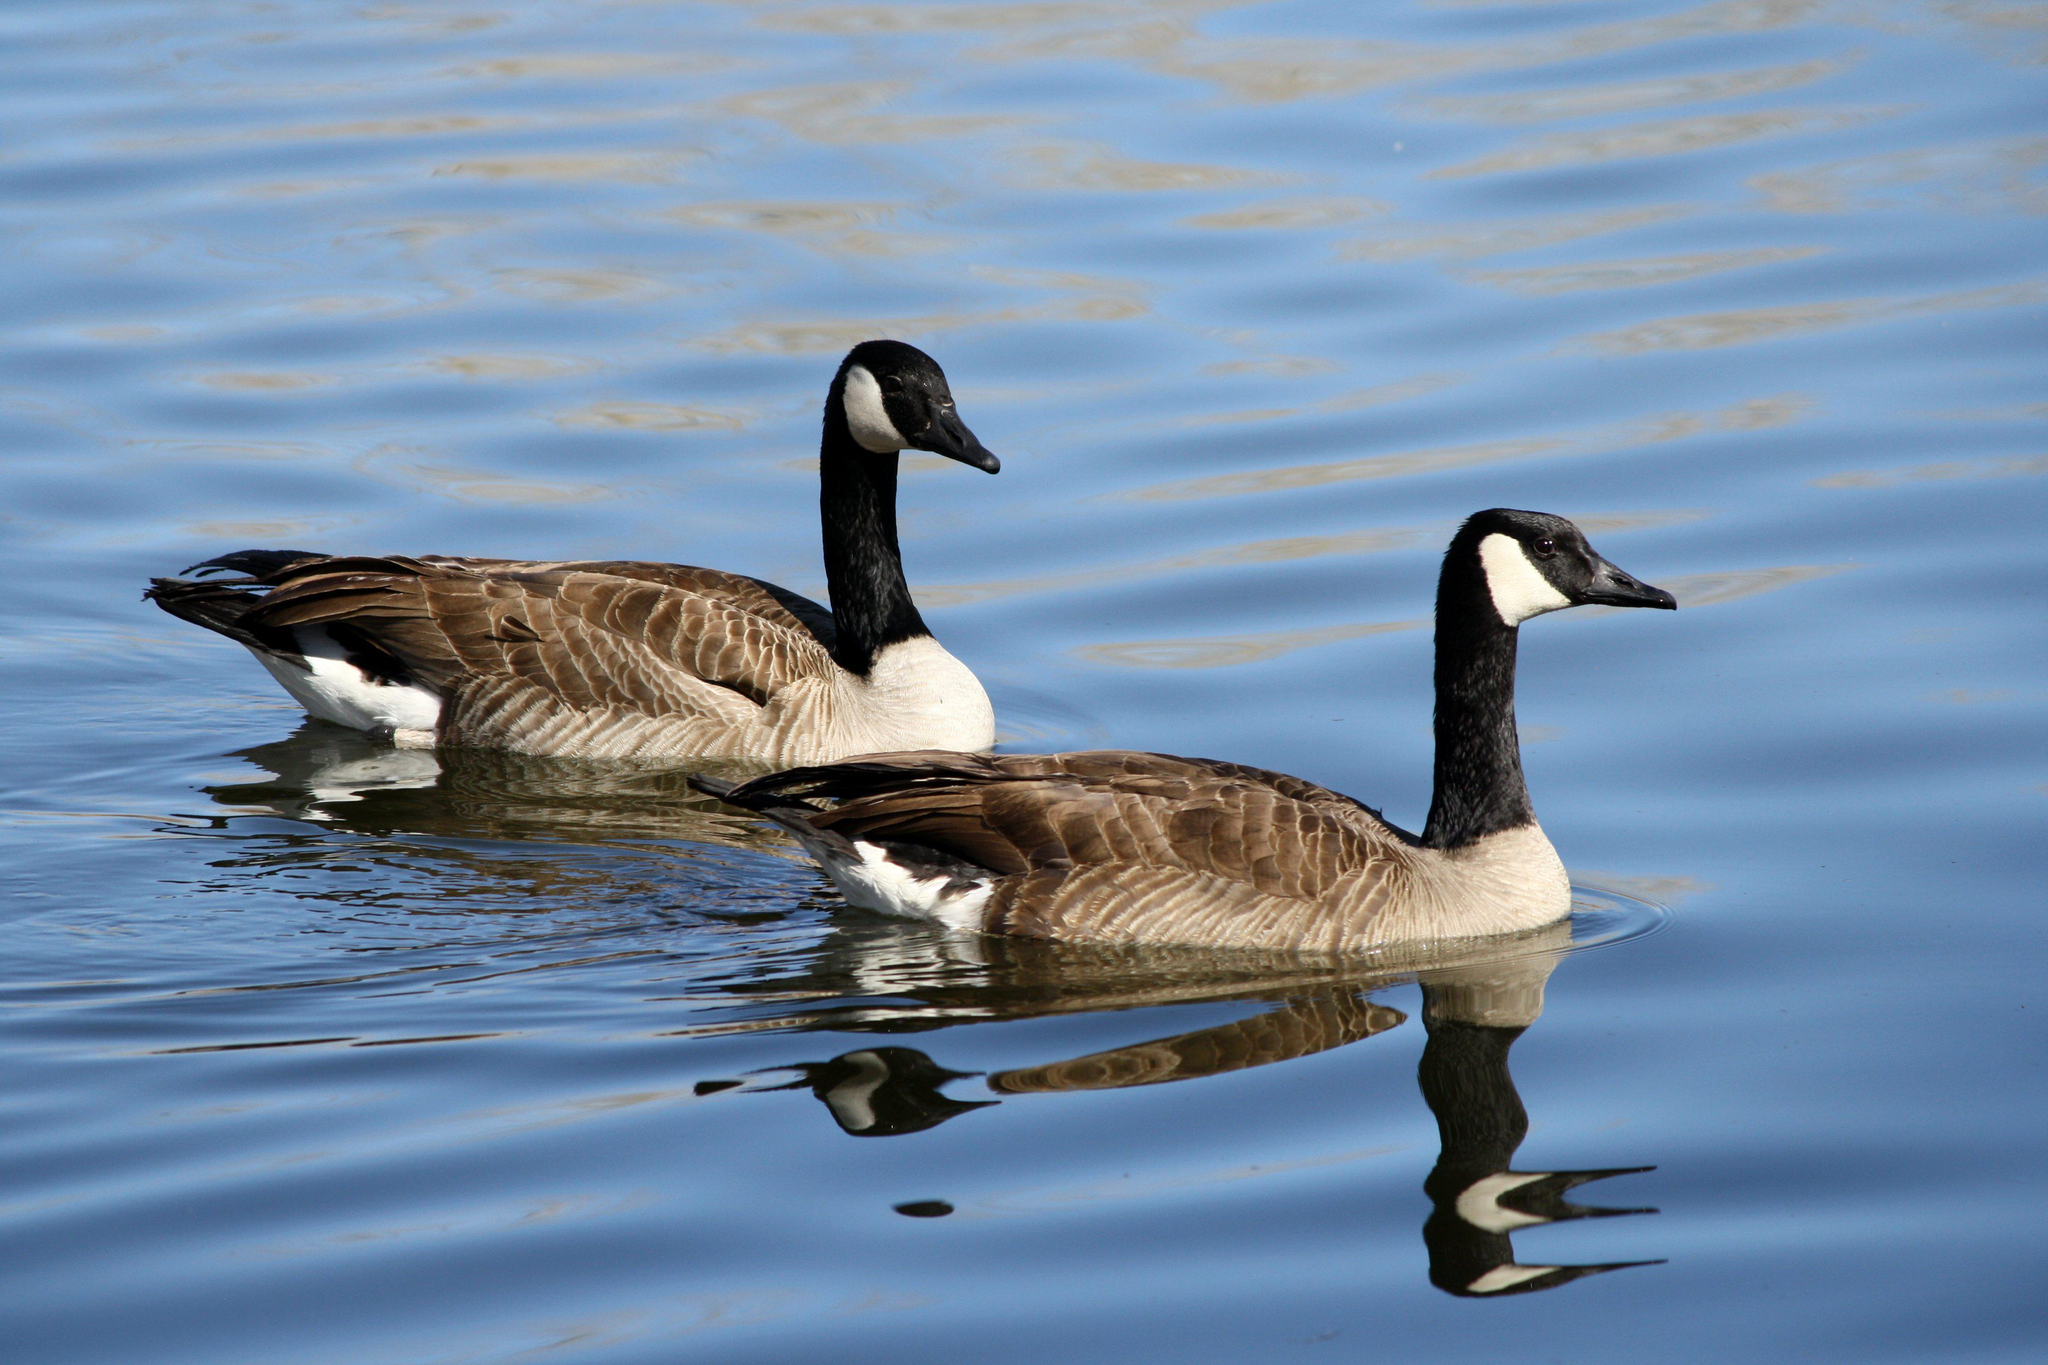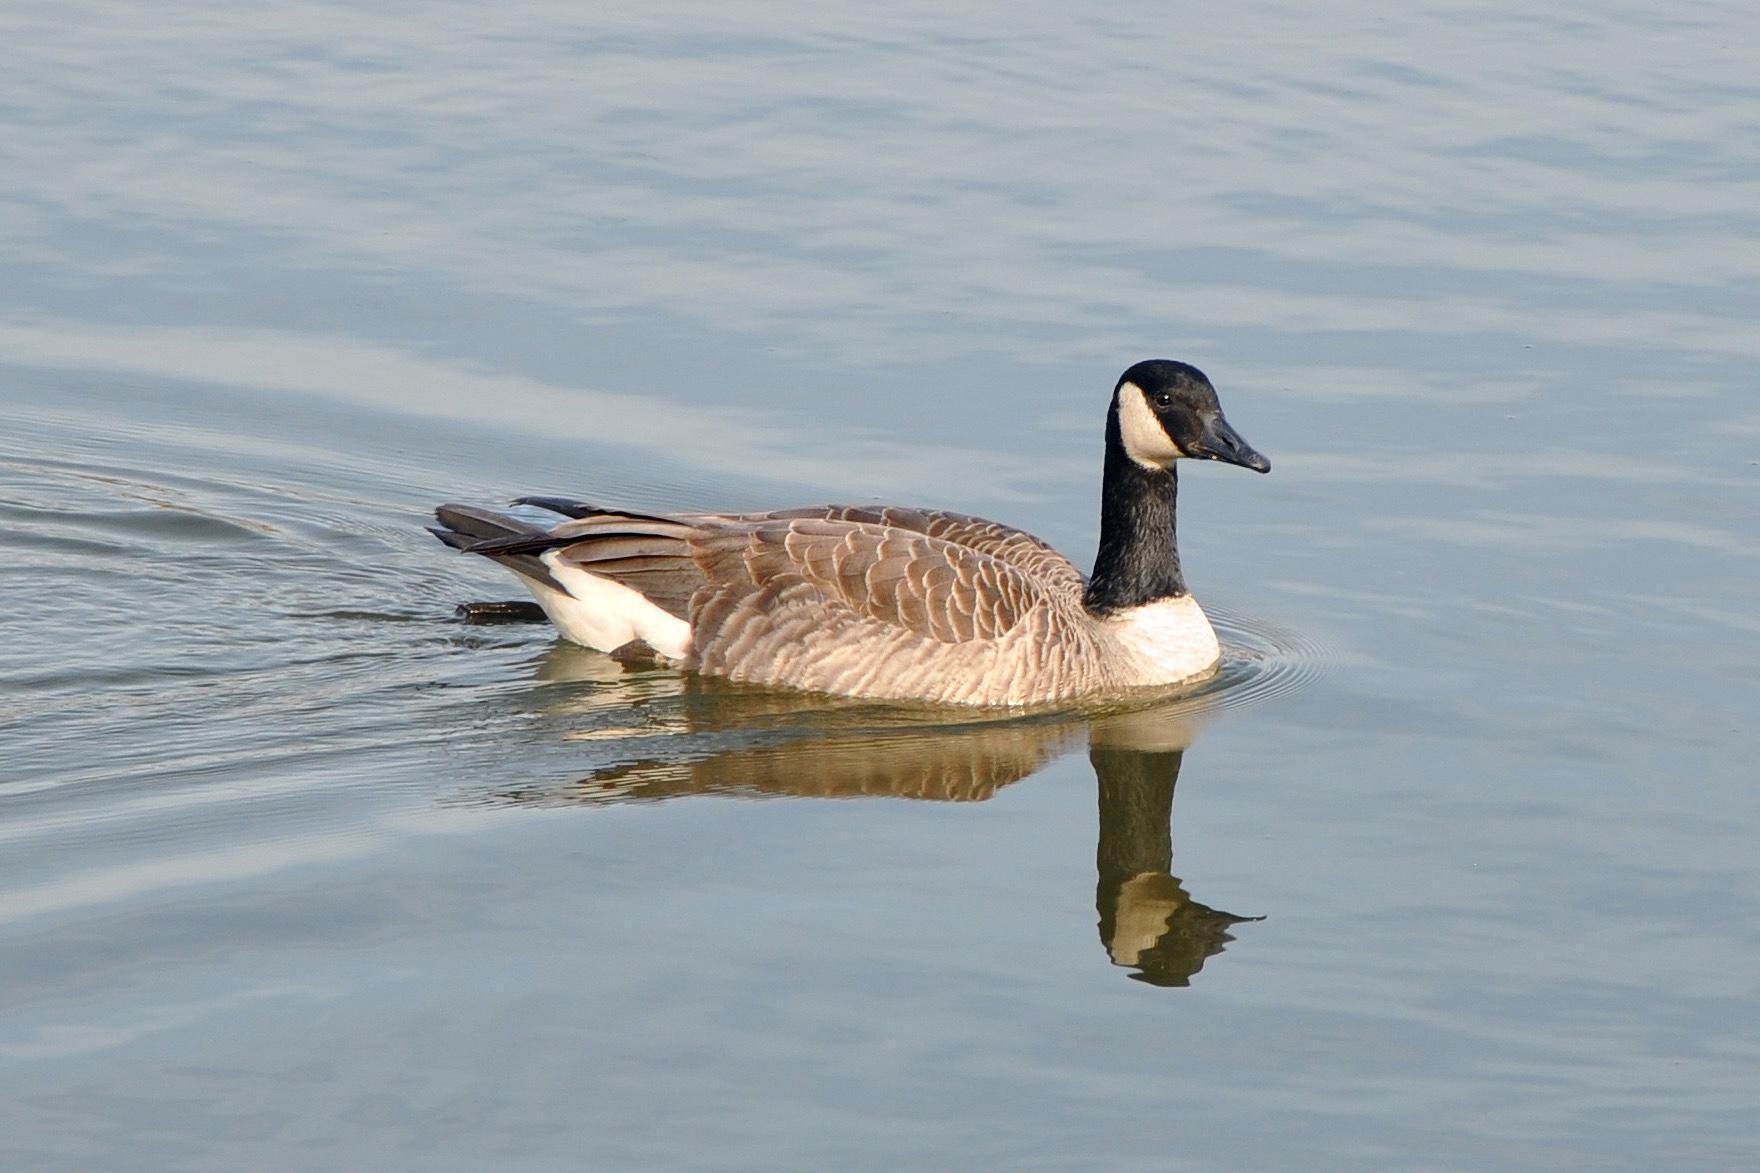The first image is the image on the left, the second image is the image on the right. For the images shown, is this caption "An image shows exactly two black-necked geese on water, both heading rightward." true? Answer yes or no. Yes. The first image is the image on the left, the second image is the image on the right. Evaluate the accuracy of this statement regarding the images: "The left image contains exactly two ducks both swimming in the same direction.". Is it true? Answer yes or no. Yes. 